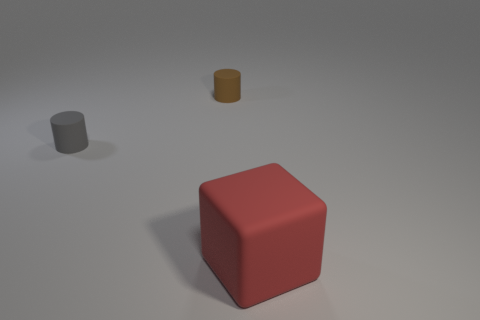Are there an equal number of small brown cylinders in front of the red cube and big metallic spheres?
Your response must be concise. Yes. What is the material of the tiny object that is to the right of the tiny thing in front of the matte cylinder that is on the right side of the tiny gray rubber thing?
Your response must be concise. Rubber. What color is the thing that is right of the tiny brown matte object?
Provide a succinct answer. Red. Is there any other thing that has the same shape as the tiny brown thing?
Keep it short and to the point. Yes. What is the size of the thing that is in front of the small matte object in front of the brown rubber thing?
Your answer should be compact. Large. Are there the same number of small cylinders that are to the right of the large red matte cube and tiny rubber cylinders that are in front of the small brown matte object?
Provide a succinct answer. No. Are there any other things that have the same size as the red matte block?
Provide a succinct answer. No. What color is the big block that is the same material as the tiny gray cylinder?
Offer a terse response. Red. What color is the object that is to the right of the gray matte thing and in front of the brown thing?
Give a very brief answer. Red. What number of balls are either matte things or tiny cyan objects?
Offer a very short reply. 0. 